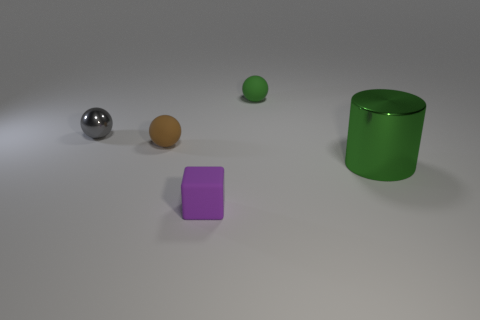Add 3 small purple shiny things. How many objects exist? 8 Subtract all gray balls. How many balls are left? 2 Subtract all spheres. How many objects are left? 2 Subtract 1 cylinders. How many cylinders are left? 0 Subtract all cyan cylinders. How many green cubes are left? 0 Subtract all brown things. Subtract all blocks. How many objects are left? 3 Add 2 small balls. How many small balls are left? 5 Add 2 large purple objects. How many large purple objects exist? 2 Subtract 0 cyan spheres. How many objects are left? 5 Subtract all green cubes. Subtract all yellow spheres. How many cubes are left? 1 